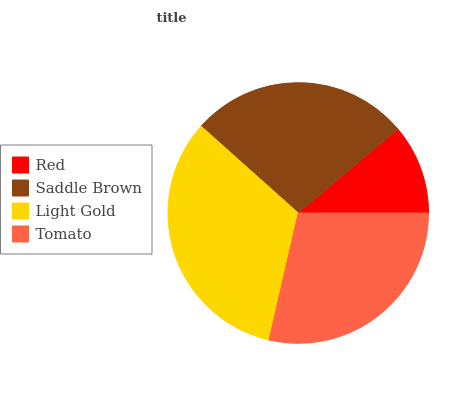Is Red the minimum?
Answer yes or no. Yes. Is Light Gold the maximum?
Answer yes or no. Yes. Is Saddle Brown the minimum?
Answer yes or no. No. Is Saddle Brown the maximum?
Answer yes or no. No. Is Saddle Brown greater than Red?
Answer yes or no. Yes. Is Red less than Saddle Brown?
Answer yes or no. Yes. Is Red greater than Saddle Brown?
Answer yes or no. No. Is Saddle Brown less than Red?
Answer yes or no. No. Is Tomato the high median?
Answer yes or no. Yes. Is Saddle Brown the low median?
Answer yes or no. Yes. Is Light Gold the high median?
Answer yes or no. No. Is Light Gold the low median?
Answer yes or no. No. 